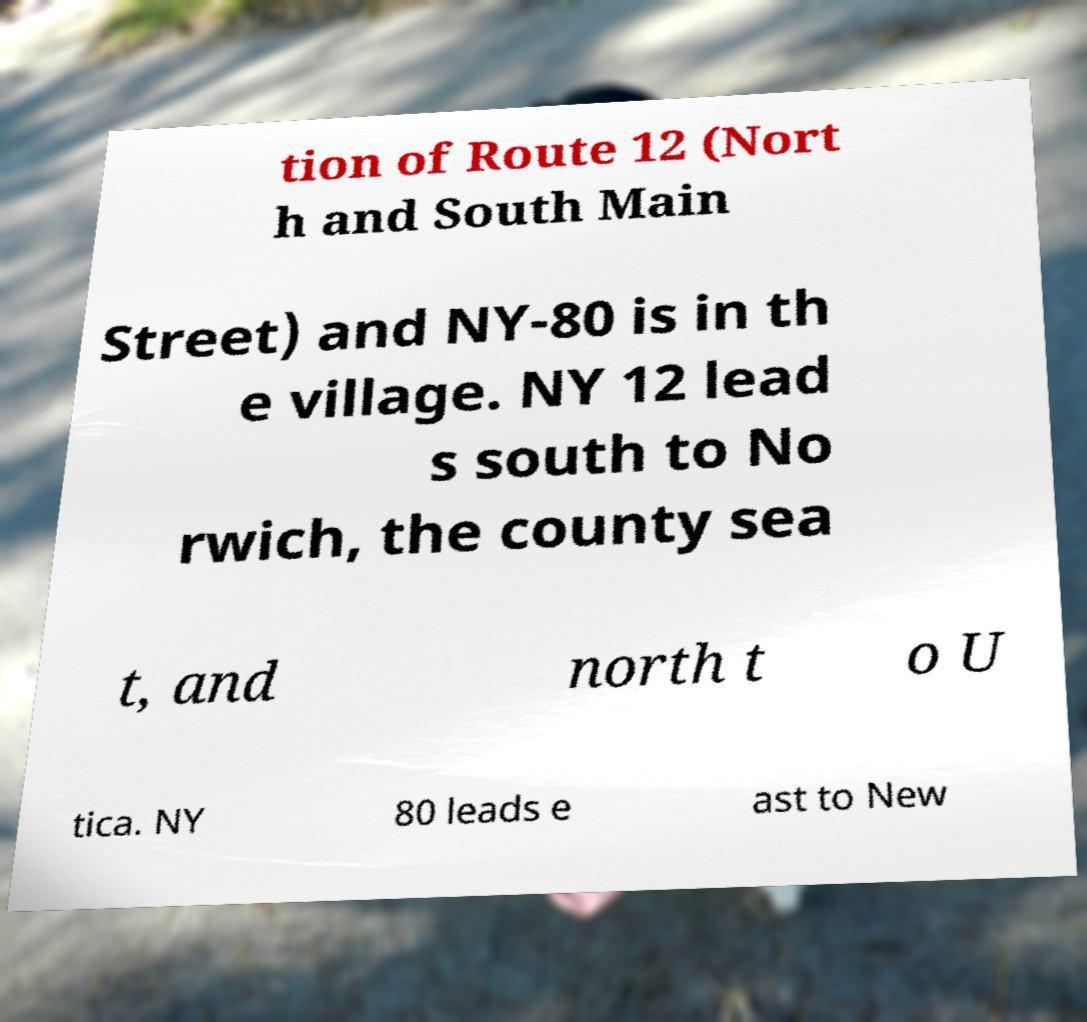There's text embedded in this image that I need extracted. Can you transcribe it verbatim? tion of Route 12 (Nort h and South Main Street) and NY-80 is in th e village. NY 12 lead s south to No rwich, the county sea t, and north t o U tica. NY 80 leads e ast to New 